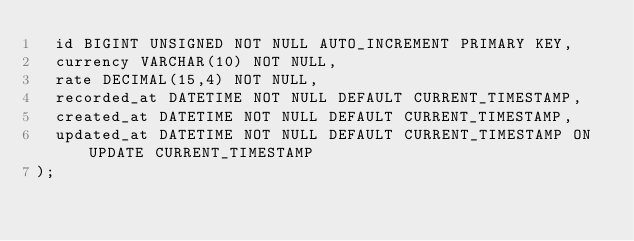<code> <loc_0><loc_0><loc_500><loc_500><_SQL_>  id BIGINT UNSIGNED NOT NULL AUTO_INCREMENT PRIMARY KEY,
  currency VARCHAR(10) NOT NULL,
  rate DECIMAL(15,4) NOT NULL,
  recorded_at DATETIME NOT NULL DEFAULT CURRENT_TIMESTAMP,
  created_at DATETIME NOT NULL DEFAULT CURRENT_TIMESTAMP,
  updated_at DATETIME NOT NULL DEFAULT CURRENT_TIMESTAMP ON UPDATE CURRENT_TIMESTAMP
);
</code> 